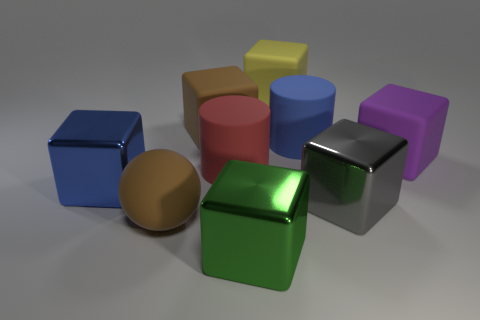Subtract all large purple matte blocks. How many blocks are left? 5 Subtract 2 blocks. How many blocks are left? 4 Subtract all blue blocks. How many blocks are left? 5 Subtract all spheres. How many objects are left? 8 Subtract all green blocks. Subtract all yellow spheres. How many blocks are left? 5 Subtract 1 yellow cubes. How many objects are left? 8 Subtract all big purple matte balls. Subtract all large objects. How many objects are left? 0 Add 2 big blue shiny blocks. How many big blue shiny blocks are left? 3 Add 9 tiny brown metal cylinders. How many tiny brown metal cylinders exist? 9 